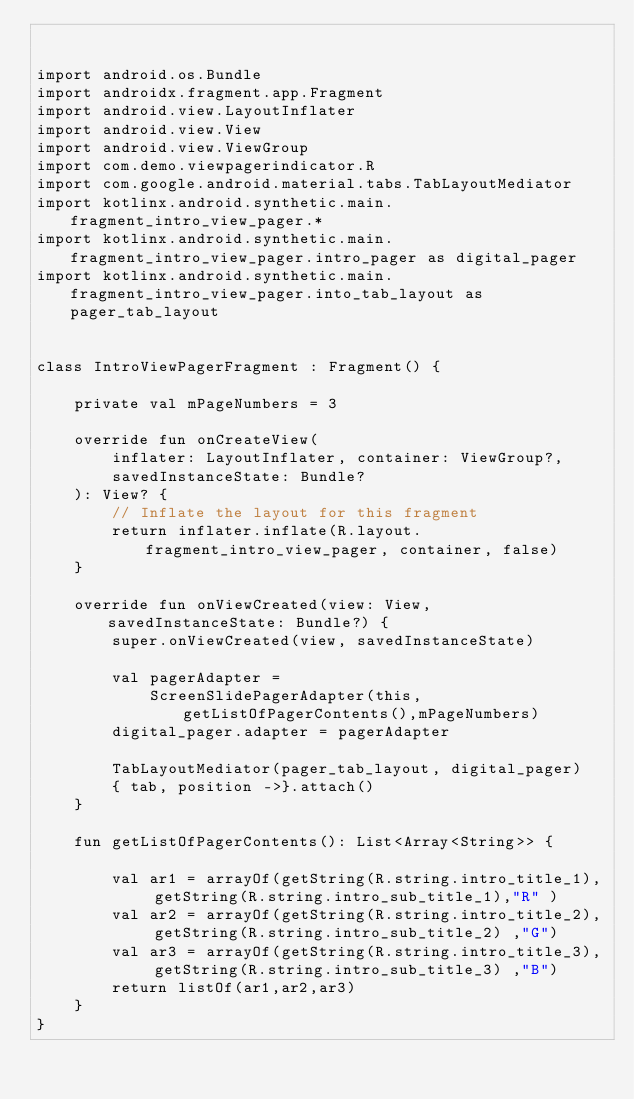<code> <loc_0><loc_0><loc_500><loc_500><_Kotlin_>

import android.os.Bundle
import androidx.fragment.app.Fragment
import android.view.LayoutInflater
import android.view.View
import android.view.ViewGroup
import com.demo.viewpagerindicator.R
import com.google.android.material.tabs.TabLayoutMediator
import kotlinx.android.synthetic.main.fragment_intro_view_pager.*
import kotlinx.android.synthetic.main.fragment_intro_view_pager.intro_pager as digital_pager
import kotlinx.android.synthetic.main.fragment_intro_view_pager.into_tab_layout as pager_tab_layout


class IntroViewPagerFragment : Fragment() {

    private val mPageNumbers = 3

    override fun onCreateView(
        inflater: LayoutInflater, container: ViewGroup?,
        savedInstanceState: Bundle?
    ): View? {
        // Inflate the layout for this fragment
        return inflater.inflate(R.layout.fragment_intro_view_pager, container, false)
    }

    override fun onViewCreated(view: View, savedInstanceState: Bundle?) {
        super.onViewCreated(view, savedInstanceState)

        val pagerAdapter =
            ScreenSlidePagerAdapter(this,getListOfPagerContents(),mPageNumbers)
        digital_pager.adapter = pagerAdapter

        TabLayoutMediator(pager_tab_layout, digital_pager)
        { tab, position ->}.attach()
    }

    fun getListOfPagerContents(): List<Array<String>> {

        val ar1 = arrayOf(getString(R.string.intro_title_1), getString(R.string.intro_sub_title_1),"R" )
        val ar2 = arrayOf(getString(R.string.intro_title_2), getString(R.string.intro_sub_title_2) ,"G")
        val ar3 = arrayOf(getString(R.string.intro_title_3), getString(R.string.intro_sub_title_3) ,"B")
        return listOf(ar1,ar2,ar3)
    }
}
</code> 